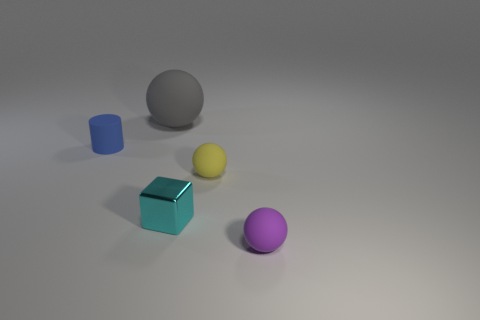Subtract all small purple matte spheres. How many spheres are left? 2 Add 3 big purple cubes. How many objects exist? 8 Subtract 0 yellow blocks. How many objects are left? 5 Subtract all cubes. How many objects are left? 4 Subtract 1 cylinders. How many cylinders are left? 0 Subtract all cyan spheres. Subtract all green blocks. How many spheres are left? 3 Subtract all green blocks. How many brown cylinders are left? 0 Subtract all small brown rubber objects. Subtract all matte objects. How many objects are left? 1 Add 2 small rubber objects. How many small rubber objects are left? 5 Add 2 tiny balls. How many tiny balls exist? 4 